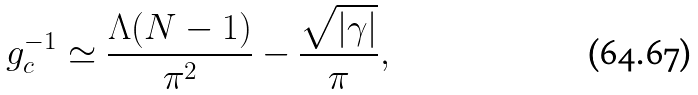Convert formula to latex. <formula><loc_0><loc_0><loc_500><loc_500>g _ { c } ^ { - 1 } \simeq \frac { \Lambda ( N - 1 ) } { \pi ^ { 2 } } - \frac { \sqrt { | \gamma | } } { \pi } ,</formula> 